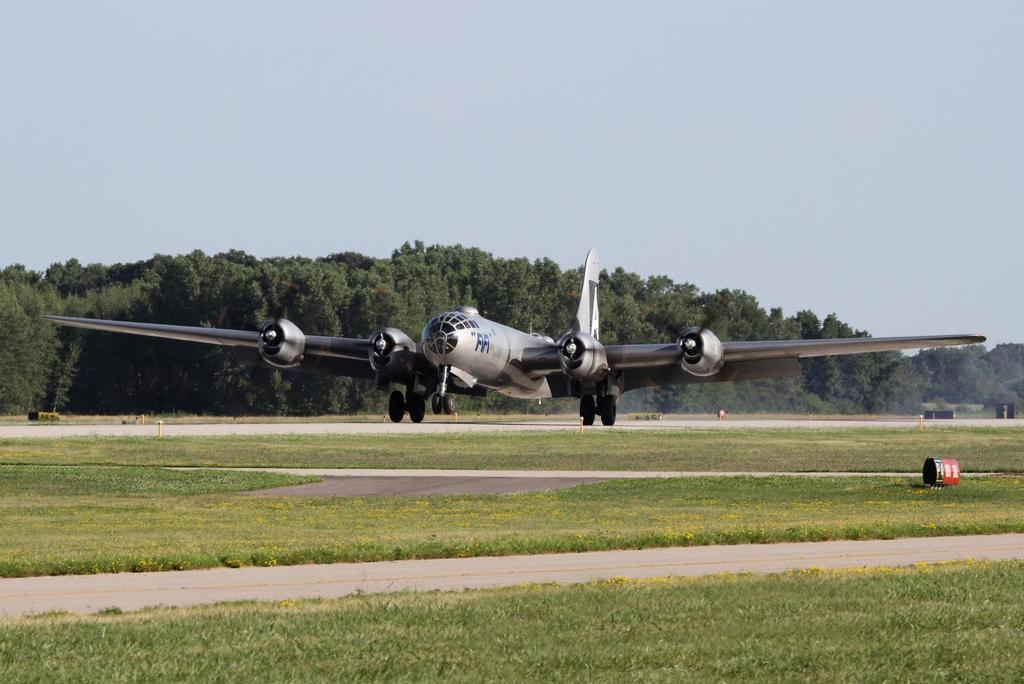What is located on the runway in the image? There is an airplane on the runway in the image. What can be seen in the background of the image? There are trees in the background of the image. What is visible at the top of the image? The sky is visible at the top of the image. What type of vegetation is on the ground in the image? There is grass on the ground in the image. Where is the plastic vase connected to the airplane in the image? There is no plastic vase or connection to the airplane present in the image. 